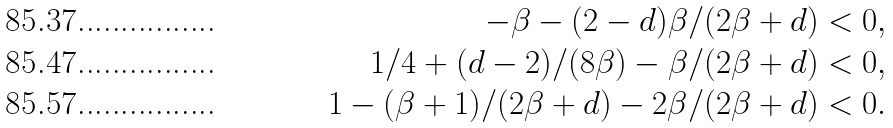<formula> <loc_0><loc_0><loc_500><loc_500>- \beta - ( 2 - d ) \beta / ( 2 \beta + d ) & < 0 , \\ 1 / 4 + ( d - 2 ) / ( 8 \beta ) - \beta / ( 2 \beta + d ) & < 0 , \\ 1 - ( \beta + 1 ) / ( 2 \beta + d ) - 2 \beta / ( 2 \beta + d ) & < 0 .</formula> 